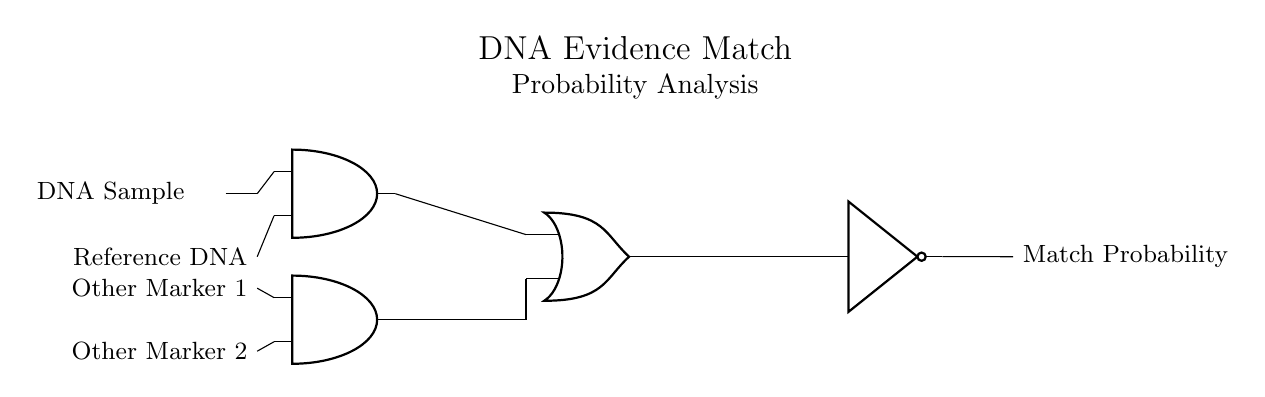What does the AND gate represent in the circuit? The AND gate represents the condition where both the DNA sample and the reference DNA must match for a successful comparison, indicating a match.
Answer: Match condition What are the inputs to the OR gate? The inputs to the OR gate are the output from the AND gate (DNA match) and the output from another AND gate (other markers), representing alternative matching conditions.
Answer: DNA match and other markers How many markers are analyzed in the circuit? Two markers are analyzed as indicated by the presence of the "Other Marker 1" and "Other Marker 2" inputs into the AND gate that feeds into the OR gate.
Answer: Two What type of logic gate is used for exclusion probability? The NOT gate is utilized to calculate exclusion probability, negating the combined match probabilities from the OR gate output.
Answer: NOT gate What is the final output of the circuit? The final output of the circuit is the "Match Probability," which indicates the overall likelihood of a DNA match after considering all inputs and gates.
Answer: Match Probability 